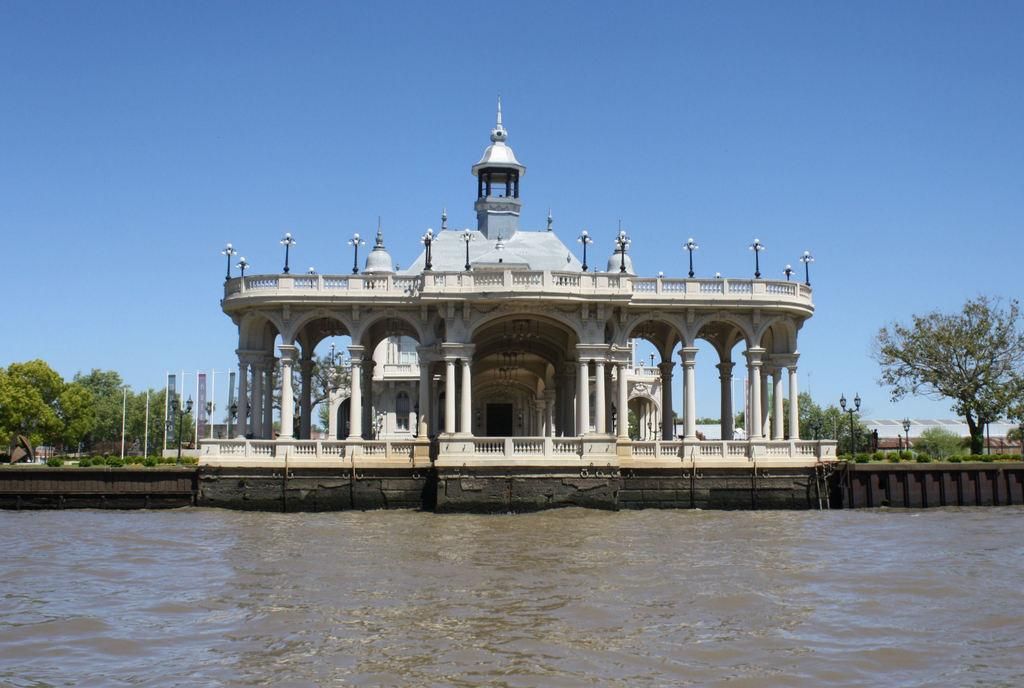What type of natural feature is present in the image? There is a river in the image. What is located behind the river? There is a building behind the river. What can be seen on the building? The building has lamps on it. What type of vegetation is near the building? There are trees near the building. What other structures are present in the image? There are flags on poles and lamp posts in the image. What type of lace is used to decorate the flags in the image? There is no lace present on the flags in the image. What time of day is depicted in the image? The provided facts do not give any information about the time of day in the image. 